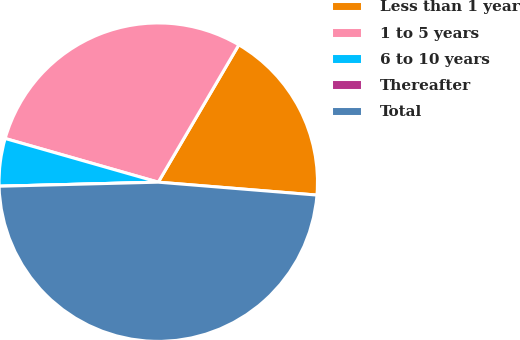Convert chart. <chart><loc_0><loc_0><loc_500><loc_500><pie_chart><fcel>Less than 1 year<fcel>1 to 5 years<fcel>6 to 10 years<fcel>Thereafter<fcel>Total<nl><fcel>17.85%<fcel>29.02%<fcel>4.83%<fcel>0.0%<fcel>48.3%<nl></chart> 